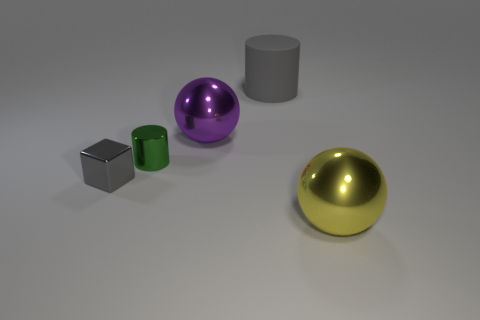Add 3 blue matte cubes. How many objects exist? 8 Subtract all blocks. How many objects are left? 4 Subtract 0 brown cylinders. How many objects are left? 5 Subtract all big cyan blocks. Subtract all small gray objects. How many objects are left? 4 Add 2 big purple shiny objects. How many big purple shiny objects are left? 3 Add 3 gray cylinders. How many gray cylinders exist? 4 